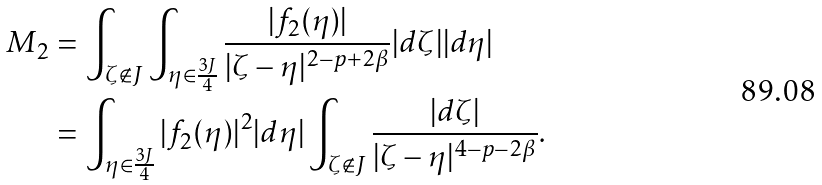<formula> <loc_0><loc_0><loc_500><loc_500>M _ { 2 } & = \int _ { \zeta \not \in J } \int _ { \eta \in \frac { 3 J } { 4 } } \frac { | f _ { 2 } ( \eta ) | } { | \zeta - \eta | ^ { 2 - p + 2 \beta } } | d \zeta | | d \eta | \\ & = \int _ { \eta \in \frac { 3 J } { 4 } } | f _ { 2 } ( \eta ) | ^ { 2 } | d \eta | \int _ { \zeta \not \in J } \frac { | d \zeta | } { | \zeta - \eta | ^ { 4 - p - 2 \beta } } .</formula> 